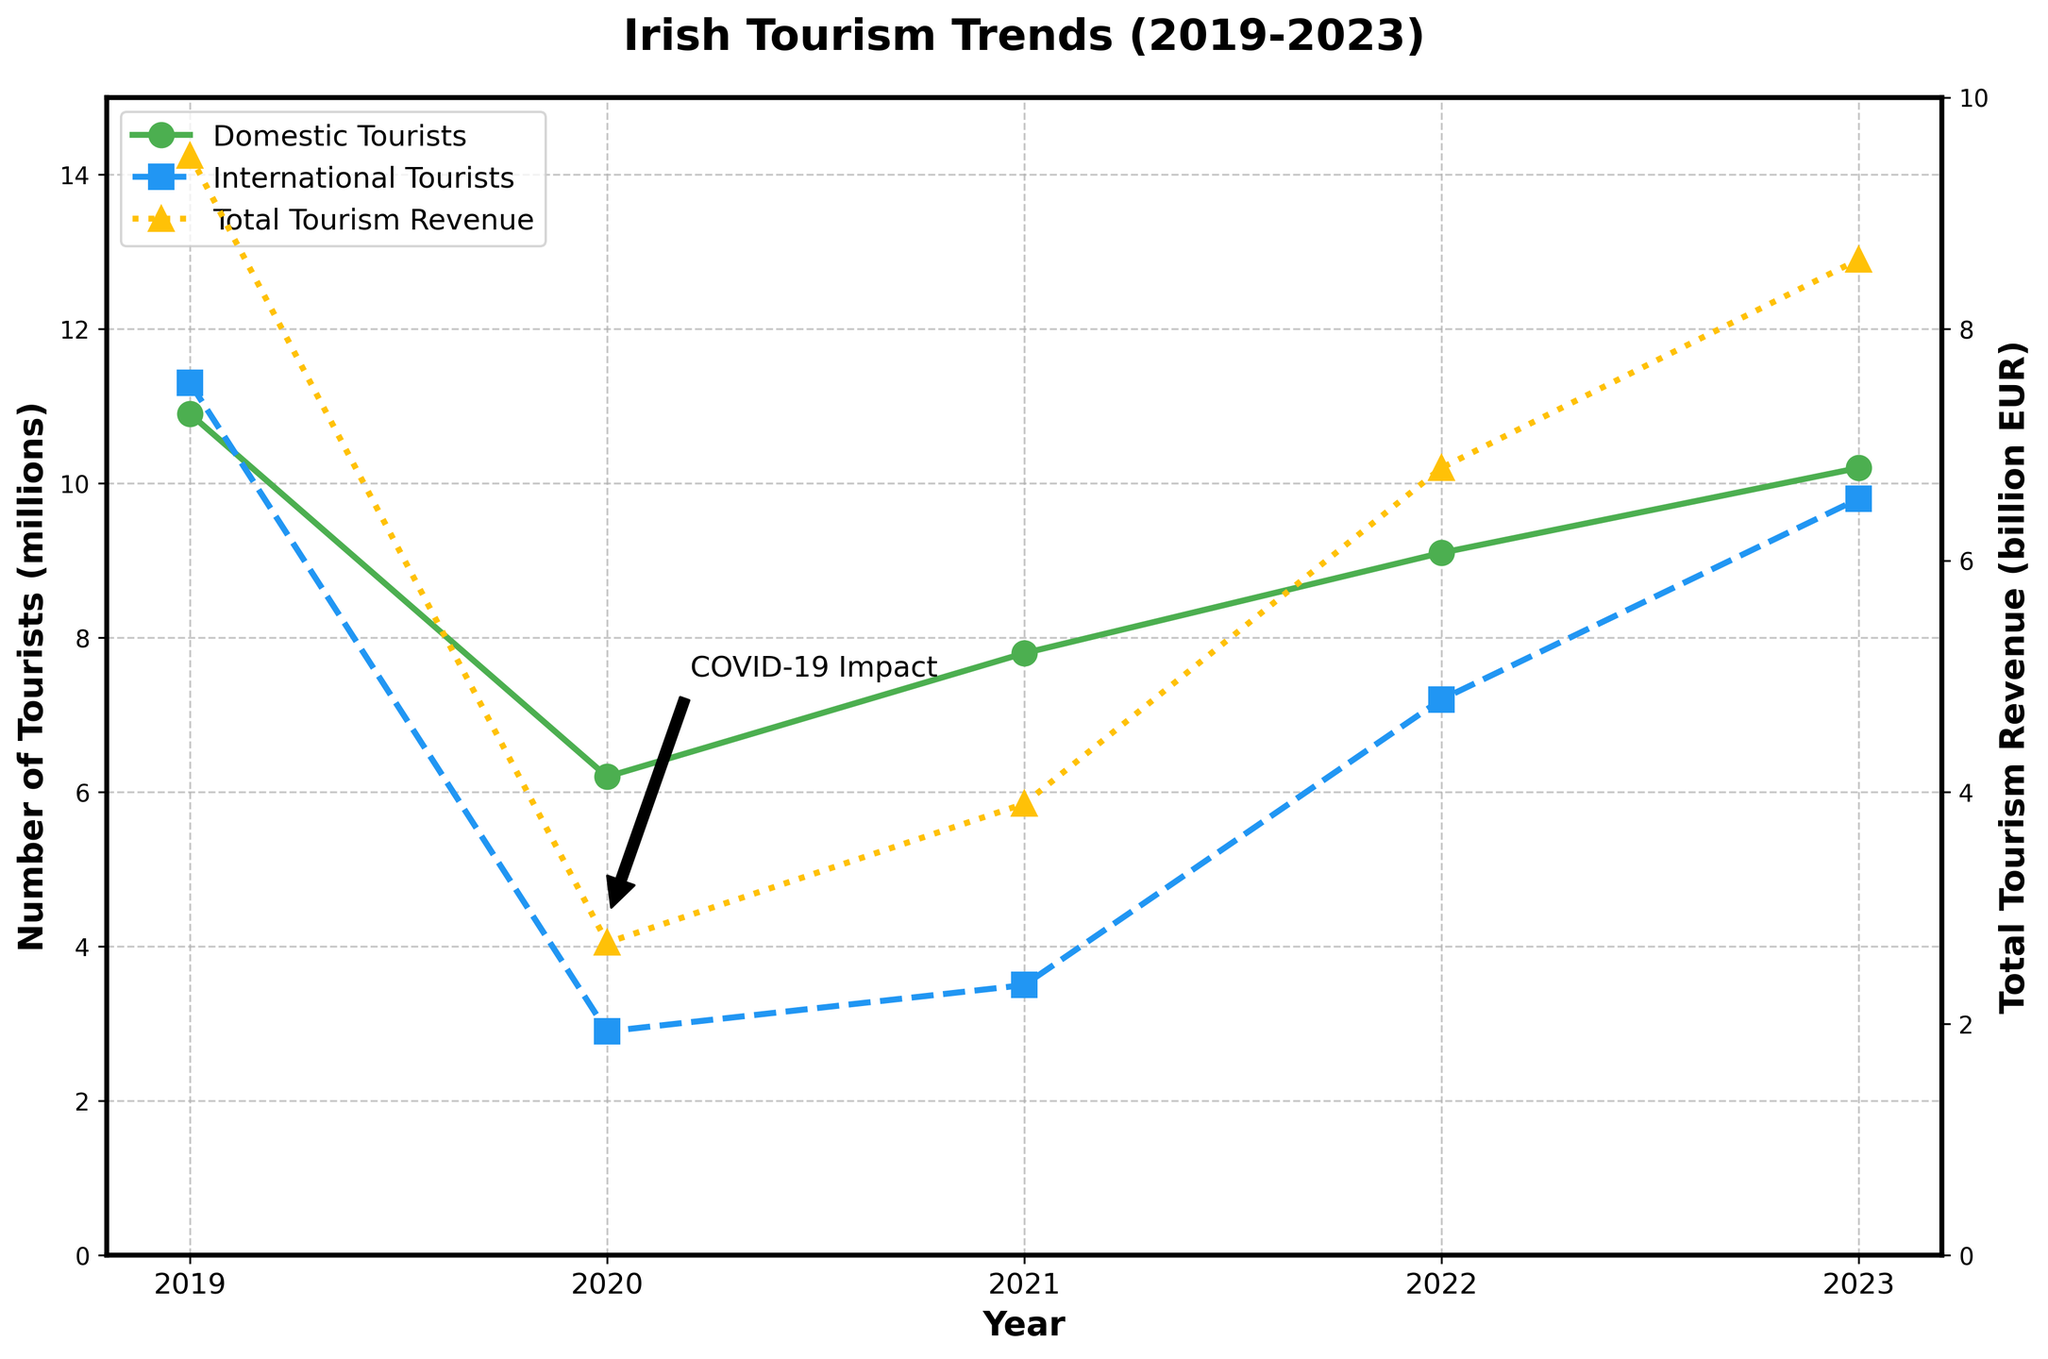What year experienced the lowest number of international tourists? The line representing international tourists reaches its lowest point on the x-axis corresponding to the year 2020.
Answer: 2020 How did the total tourism revenue change from 2019 to 2020? In 2019, the revenue was €9.5 billion. In 2020, it dropped to €2.7 billion. The change is calculated as €2.7 billion - €9.5 billion, which is a decrease of €6.8 billion.
Answer: Decreased by €6.8 billion What is the total number of tourists (domestic + international) in 2023? In 2023, the chart shows 10.2 million domestic tourists and 9.8 million international tourists. Adding these together gives 10.2 + 9.8 = 20 million.
Answer: 20 million Which segment saw a greater percentage drop from 2019 to 2020: domestic tourists or international tourists? Domestic tourists dropped from 10.9 million to 6.2 million, a 43.12% decrease ((10.9 - 6.2) / 10.9 * 100). International tourists dropped from 11.3 million to 2.9 million, a 74.34% decrease ((11.3 - 2.9) / 11.3 * 100). The international segment saw a greater percentage drop.
Answer: International tourists Between which consecutive years did total tourism revenue see the highest increase? Check the revenue for each year: 2020 (€2.7 billion), 2021 (€3.9 billion), 2022 (€6.8 billion), 2023 (€8.6 billion). The increase from 2021 to 2022 is €6.8 billion - €3.9 billion = €2.9 billion, which is higher than any other annual change.
Answer: 2021-2022 What is the difference in the number of domestic tourists between 2020 and 2022? The chart shows 6.2 million domestic tourists in 2020 and 9.1 million in 2022. The difference is 9.1 - 6.2 = 2.9 million.
Answer: 2.9 million In which year did domestic tourists begin to recover significantly after the dip due to COVID-19? After a drop in 2020 (6.2 million), the number of domestic tourists increased in 2021 to 7.8 million, showing significant recovery.
Answer: 2021 How does the number of international tourists in 2023 compare to the number in 2019? In 2023, there were 9.8 million international tourists, while in 2019 there were 11.3 million. Comparing these, 9.8 million is less than 11.3 million.
Answer: Less Which year had the highest total tourism revenue? The highest point for total tourism revenue line is in 2019 with €9.5 billion. Although 2023’s revenue is high, it does not exceed 2019's value.
Answer: 2019 How much did the total number of tourists (domestic + international) grow from 2020 to 2023? In 2020, the total number of tourists was 6.2 million (domestic) + 2.9 million (international) = 9.1 million. In 2023, it was 10.2 million (domestic) + 9.8 million (international) = 20 million. The growth is 20 million - 9.1 million = 10.9 million.
Answer: 10.9 million 